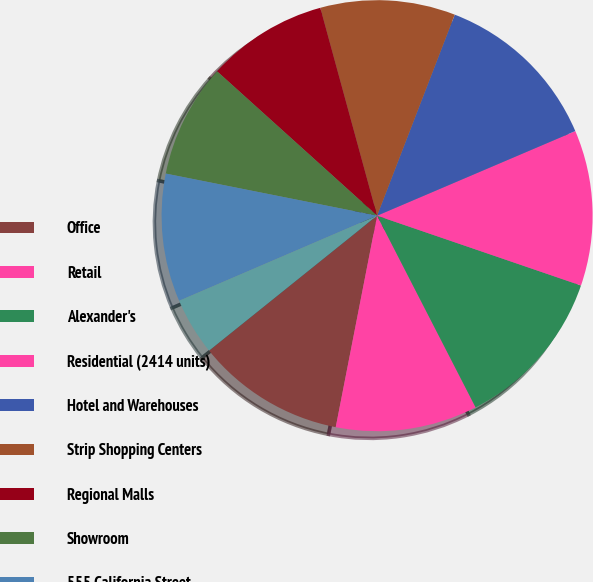Convert chart. <chart><loc_0><loc_0><loc_500><loc_500><pie_chart><fcel>Office<fcel>Retail<fcel>Alexander's<fcel>Residential (2414 units)<fcel>Hotel and Warehouses<fcel>Strip Shopping Centers<fcel>Regional Malls<fcel>Showroom<fcel>555 California Street<fcel>Primarily Warehouses<nl><fcel>11.15%<fcel>10.63%<fcel>12.19%<fcel>11.67%<fcel>12.71%<fcel>10.11%<fcel>9.07%<fcel>8.55%<fcel>9.59%<fcel>4.31%<nl></chart> 